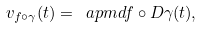Convert formula to latex. <formula><loc_0><loc_0><loc_500><loc_500>v _ { f \circ \gamma } ( t ) = \ a p m d { f } \circ D \gamma ( t ) ,</formula> 